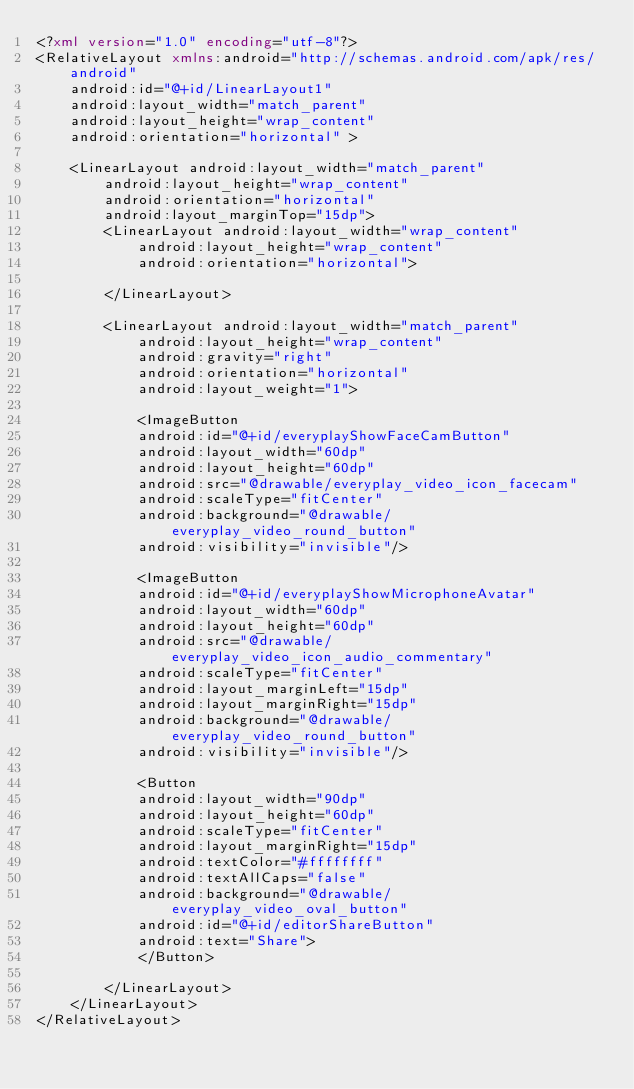Convert code to text. <code><loc_0><loc_0><loc_500><loc_500><_XML_><?xml version="1.0" encoding="utf-8"?>
<RelativeLayout xmlns:android="http://schemas.android.com/apk/res/android"
    android:id="@+id/LinearLayout1"
    android:layout_width="match_parent"
    android:layout_height="wrap_content"
    android:orientation="horizontal" >

    <LinearLayout android:layout_width="match_parent"
        android:layout_height="wrap_content"
        android:orientation="horizontal"
        android:layout_marginTop="15dp">
        <LinearLayout android:layout_width="wrap_content"
            android:layout_height="wrap_content"
            android:orientation="horizontal">

        </LinearLayout>

        <LinearLayout android:layout_width="match_parent"
            android:layout_height="wrap_content"
            android:gravity="right"
            android:orientation="horizontal" 
            android:layout_weight="1">
    
            <ImageButton
            android:id="@+id/everyplayShowFaceCamButton"
            android:layout_width="60dp"
            android:layout_height="60dp"
            android:src="@drawable/everyplay_video_icon_facecam"
            android:scaleType="fitCenter"
            android:background="@drawable/everyplay_video_round_button"
            android:visibility="invisible"/>
        
            <ImageButton
            android:id="@+id/everyplayShowMicrophoneAvatar"
            android:layout_width="60dp"
            android:layout_height="60dp"
            android:src="@drawable/everyplay_video_icon_audio_commentary"
            android:scaleType="fitCenter"
            android:layout_marginLeft="15dp"
            android:layout_marginRight="15dp"
            android:background="@drawable/everyplay_video_round_button"
            android:visibility="invisible"/>

            <Button
            android:layout_width="90dp"
            android:layout_height="60dp"
            android:scaleType="fitCenter"
            android:layout_marginRight="15dp"
            android:textColor="#ffffffff"
            android:textAllCaps="false"
            android:background="@drawable/everyplay_video_oval_button"
            android:id="@+id/editorShareButton"
            android:text="Share">
            </Button>
            
        </LinearLayout>
    </LinearLayout>
</RelativeLayout>
</code> 